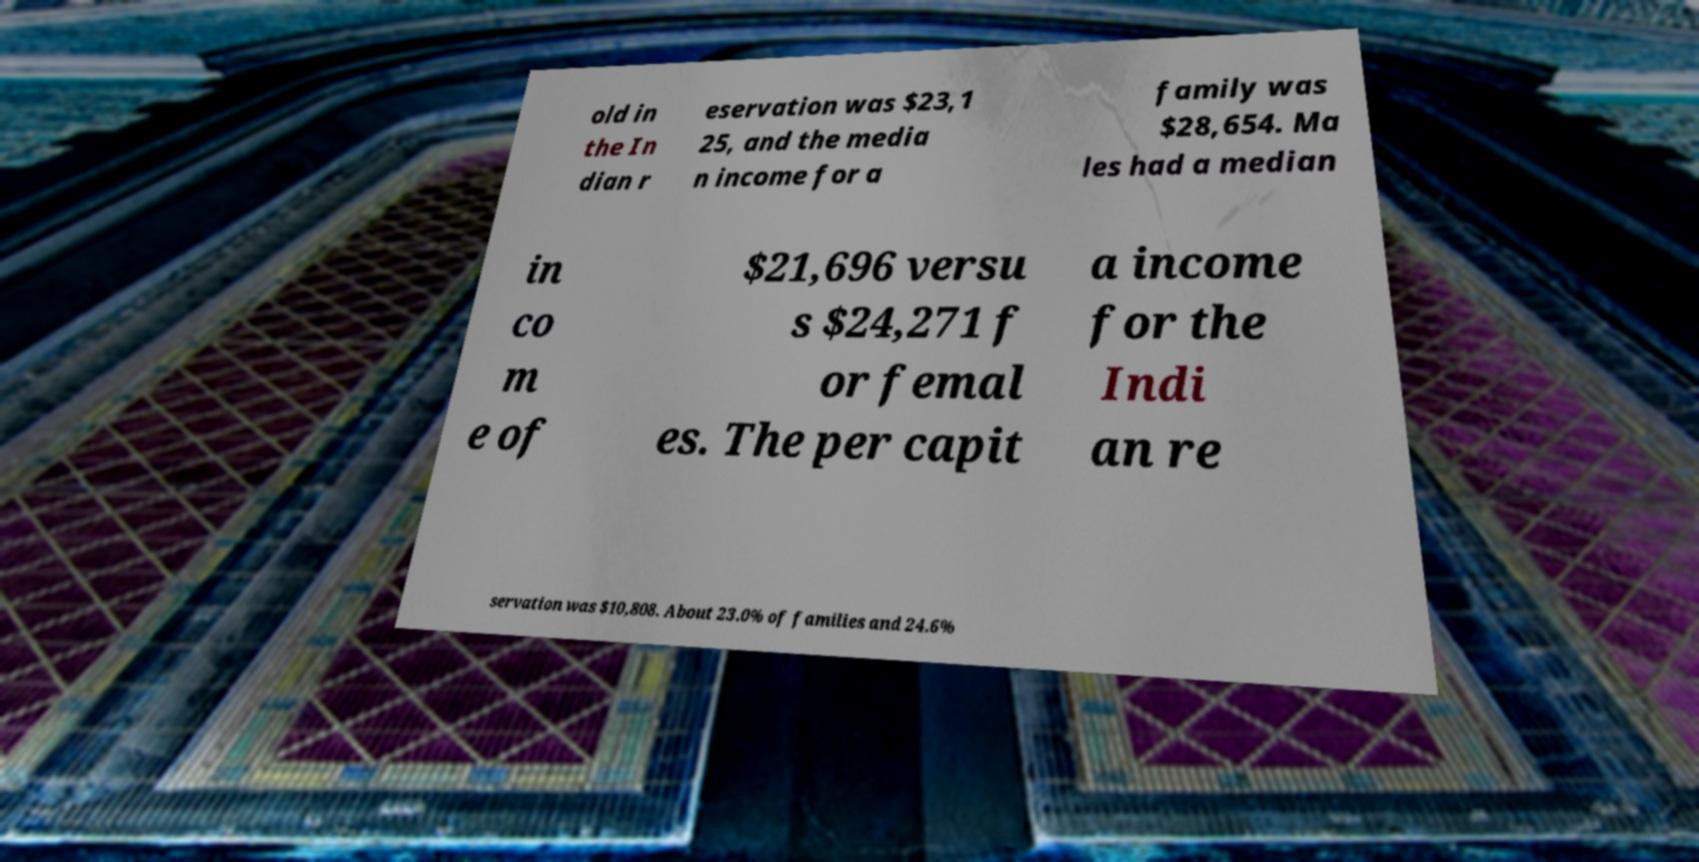What messages or text are displayed in this image? I need them in a readable, typed format. old in the In dian r eservation was $23,1 25, and the media n income for a family was $28,654. Ma les had a median in co m e of $21,696 versu s $24,271 f or femal es. The per capit a income for the Indi an re servation was $10,808. About 23.0% of families and 24.6% 